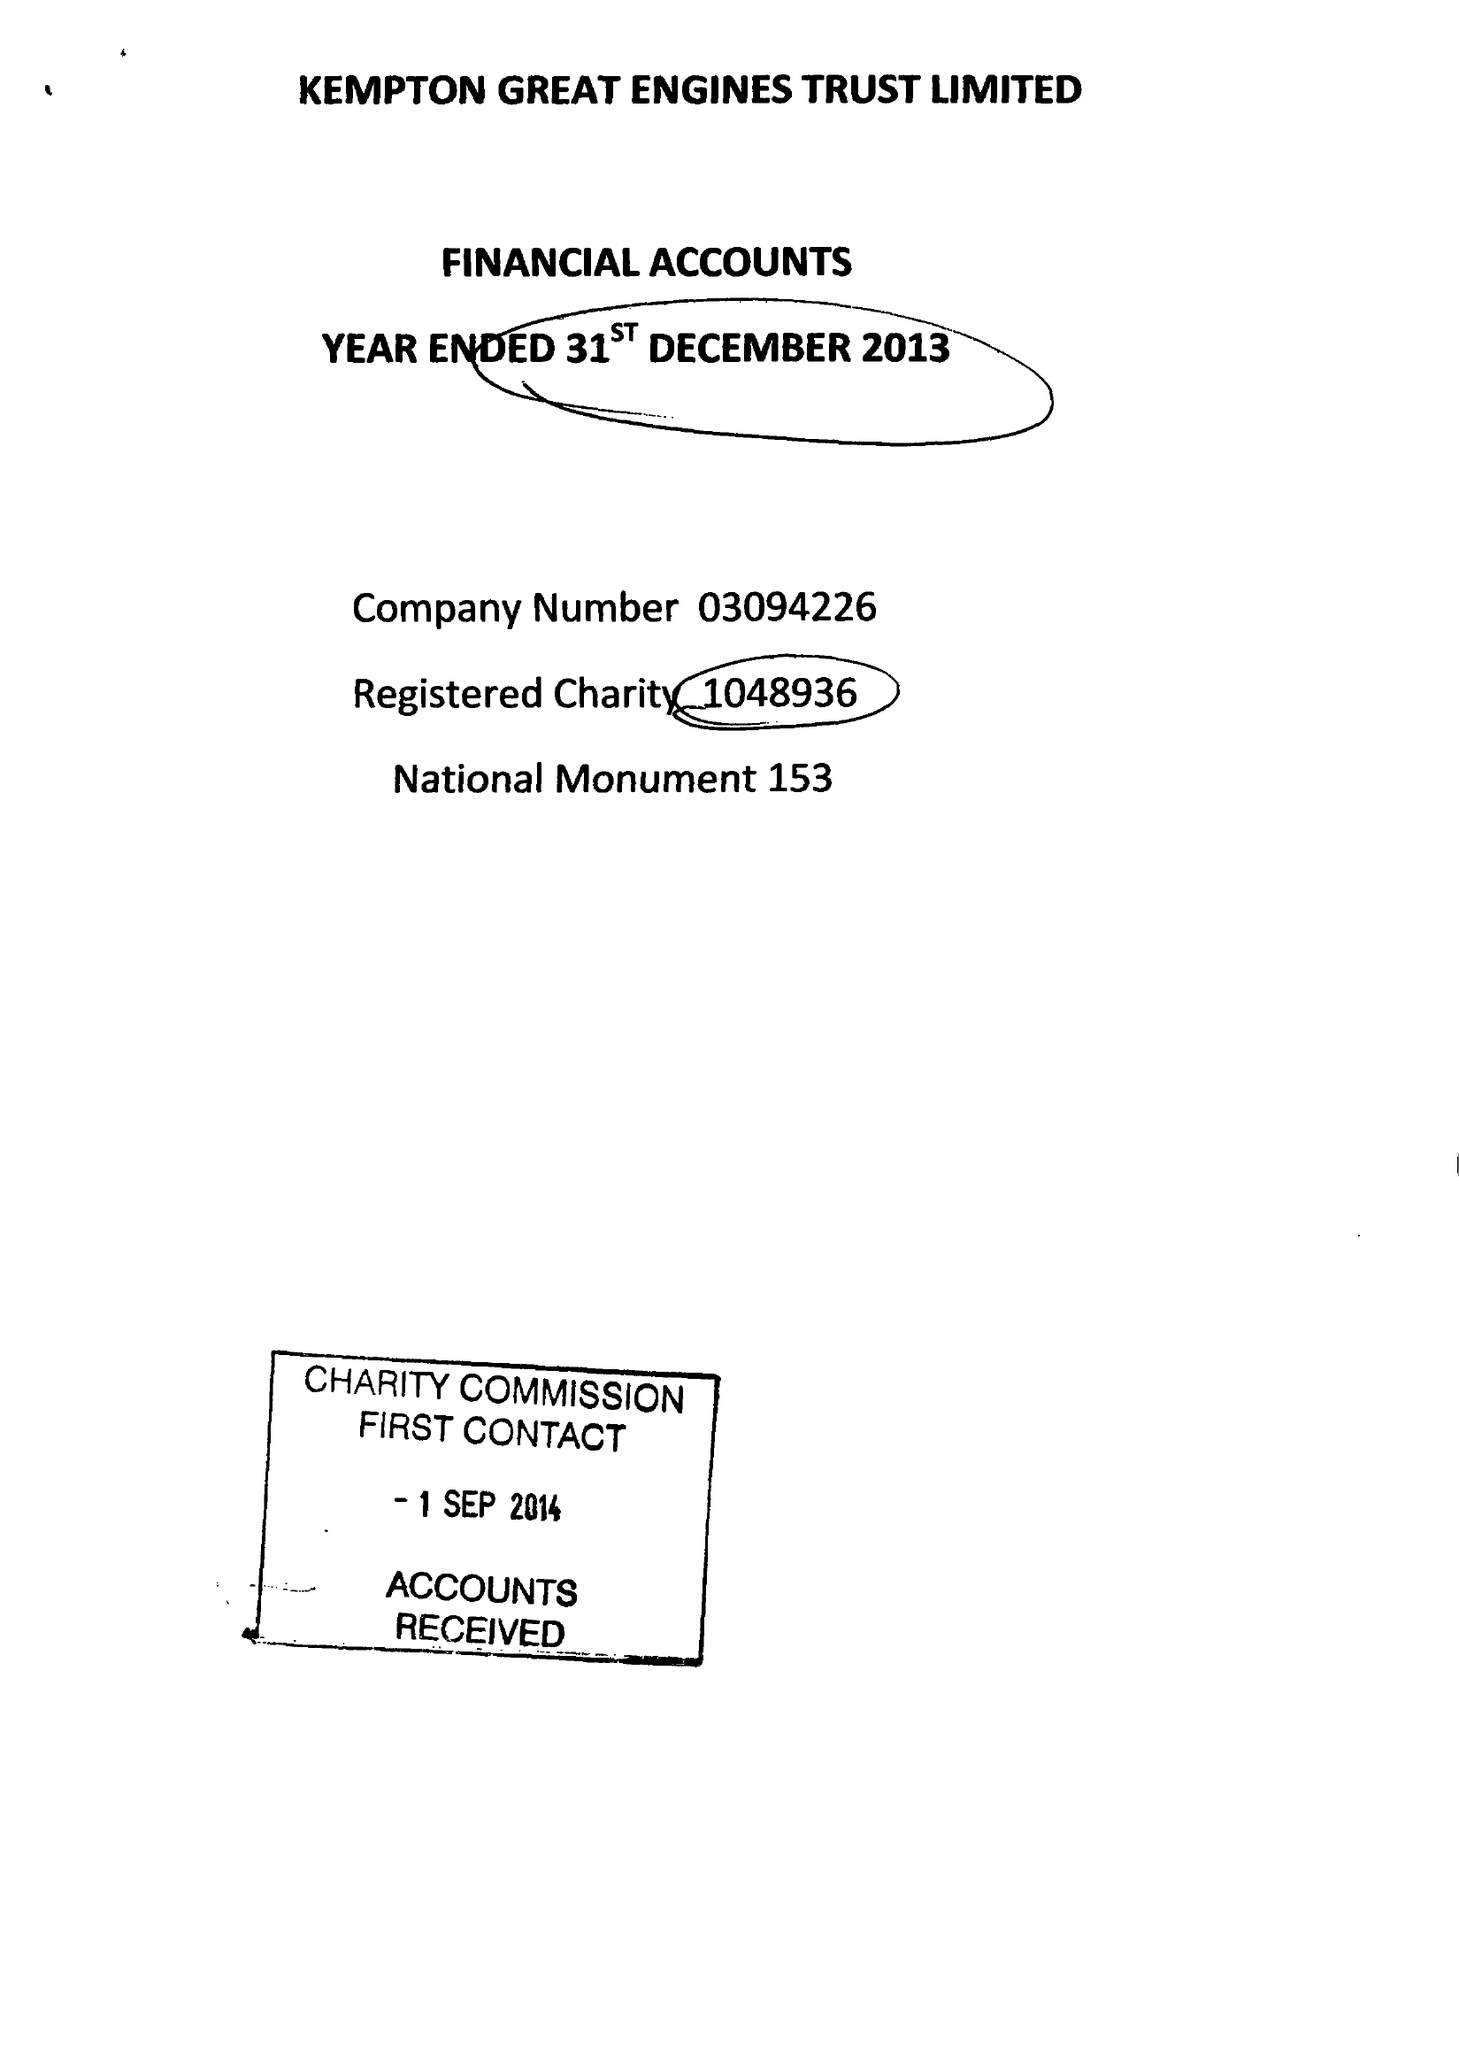What is the value for the charity_number?
Answer the question using a single word or phrase. 1048936 